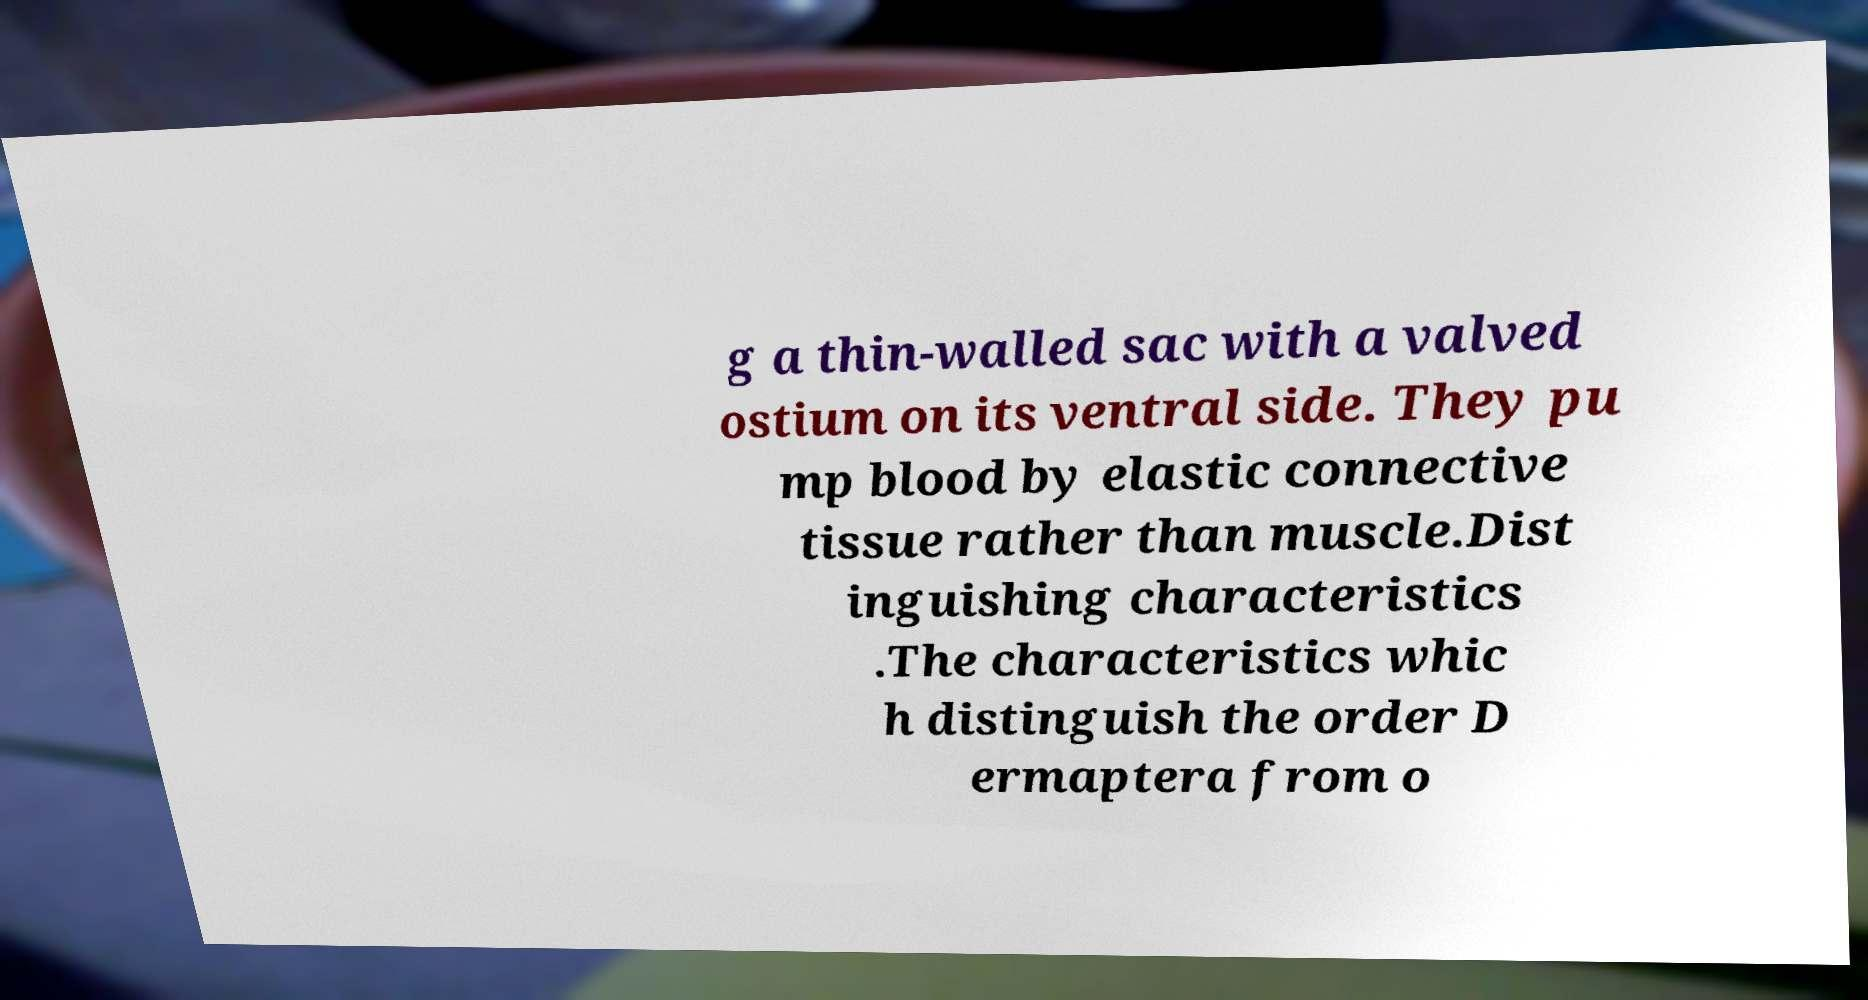There's text embedded in this image that I need extracted. Can you transcribe it verbatim? g a thin-walled sac with a valved ostium on its ventral side. They pu mp blood by elastic connective tissue rather than muscle.Dist inguishing characteristics .The characteristics whic h distinguish the order D ermaptera from o 